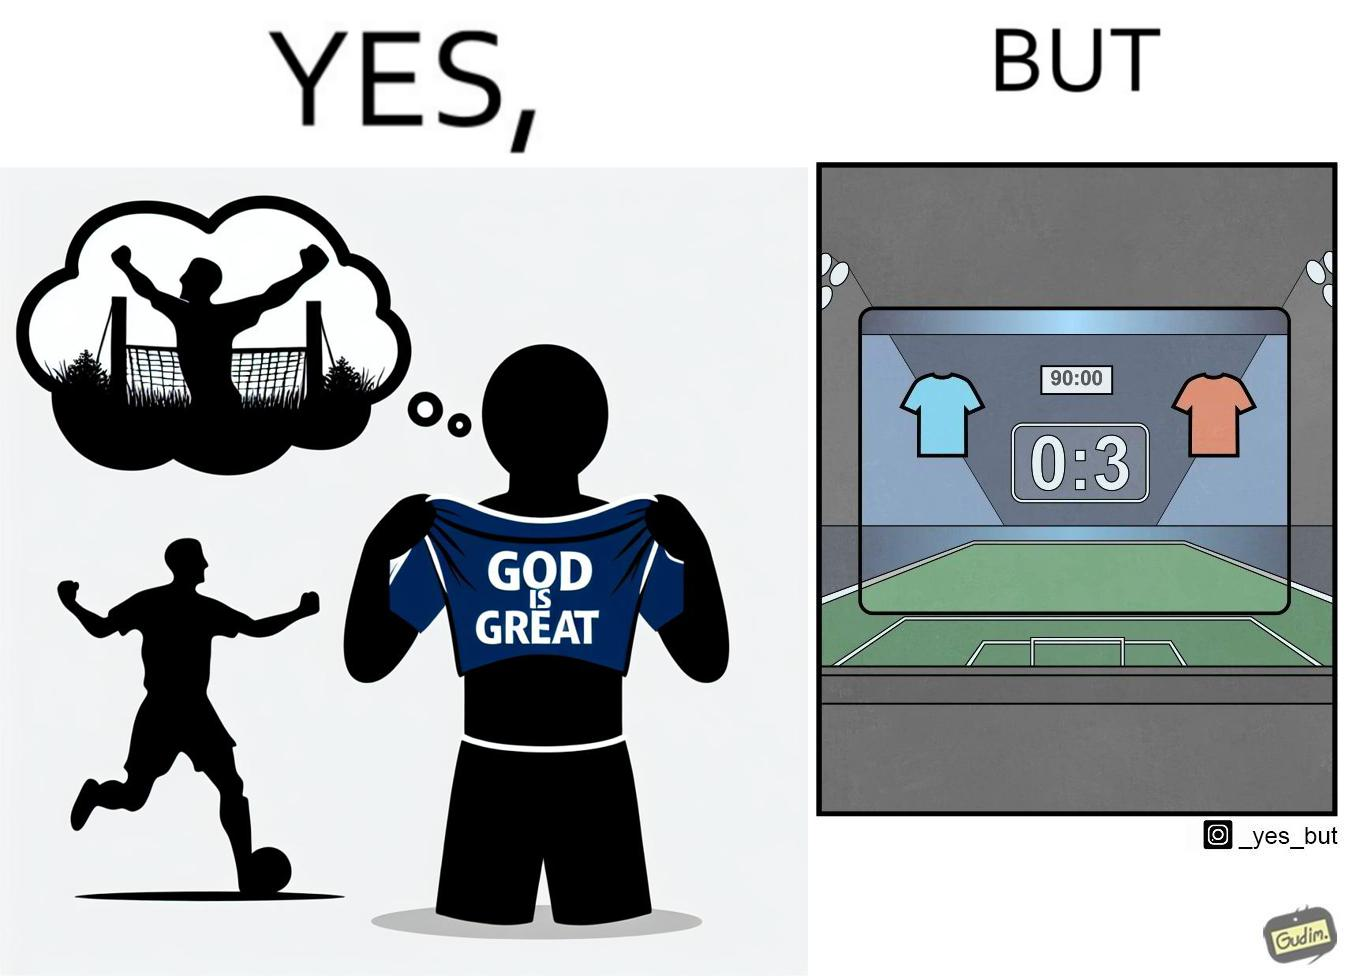Describe the content of this image. The image is funny because the player thinks that when he scores a goal he will thank the god and show his t-shirt saying "GOD IS GREAT" but he ends up not being able to score any goals meaning that God did not want him to score any goals. 